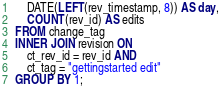Convert code to text. <code><loc_0><loc_0><loc_500><loc_500><_SQL_>    DATE(LEFT(rev_timestamp, 8)) AS day,
    COUNT(rev_id) AS edits
FROM change_tag
INNER JOIN revision ON
    ct_rev_id = rev_id AND
    ct_tag = "gettingstarted edit"
GROUP BY 1;
</code> 